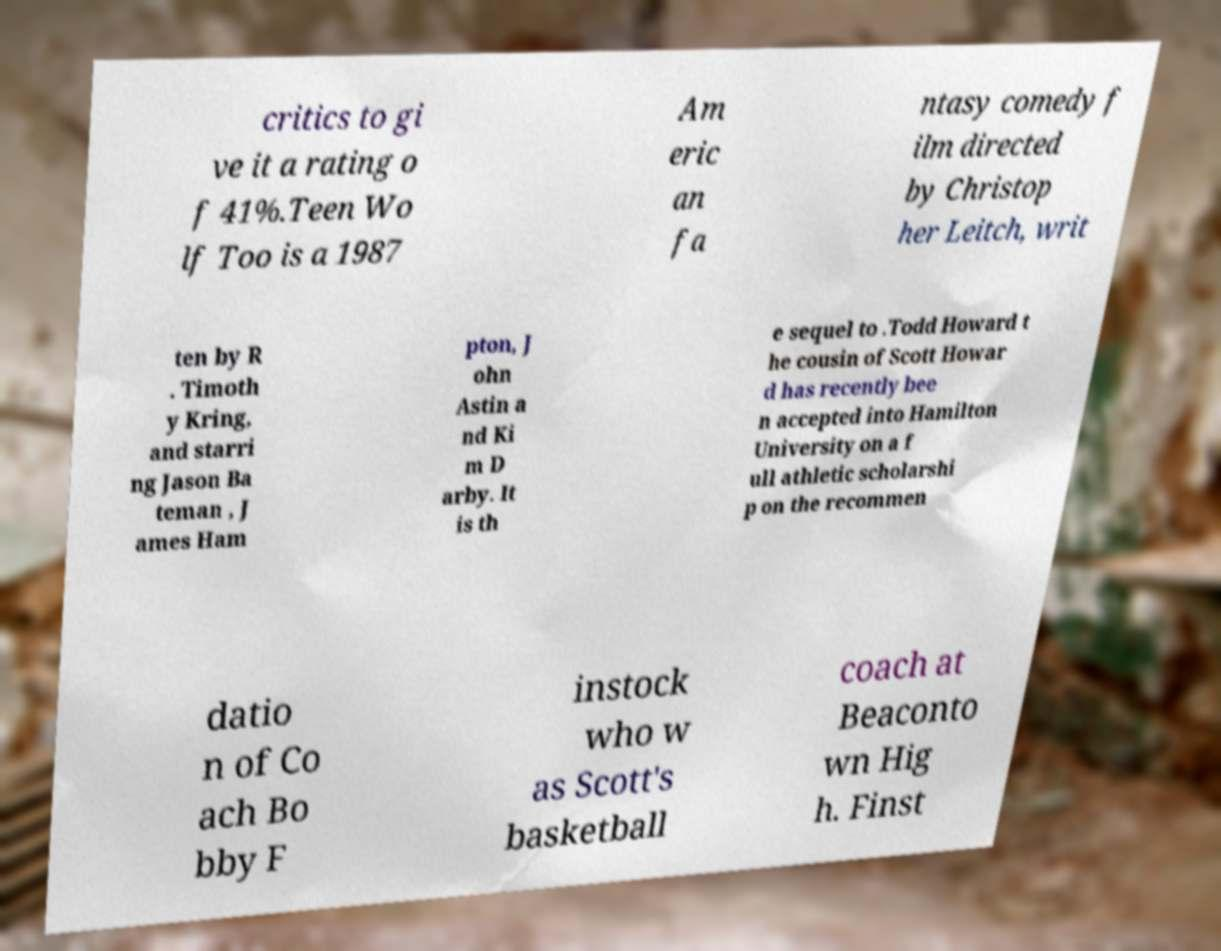What messages or text are displayed in this image? I need them in a readable, typed format. critics to gi ve it a rating o f 41%.Teen Wo lf Too is a 1987 Am eric an fa ntasy comedy f ilm directed by Christop her Leitch, writ ten by R . Timoth y Kring, and starri ng Jason Ba teman , J ames Ham pton, J ohn Astin a nd Ki m D arby. It is th e sequel to .Todd Howard t he cousin of Scott Howar d has recently bee n accepted into Hamilton University on a f ull athletic scholarshi p on the recommen datio n of Co ach Bo bby F instock who w as Scott's basketball coach at Beaconto wn Hig h. Finst 